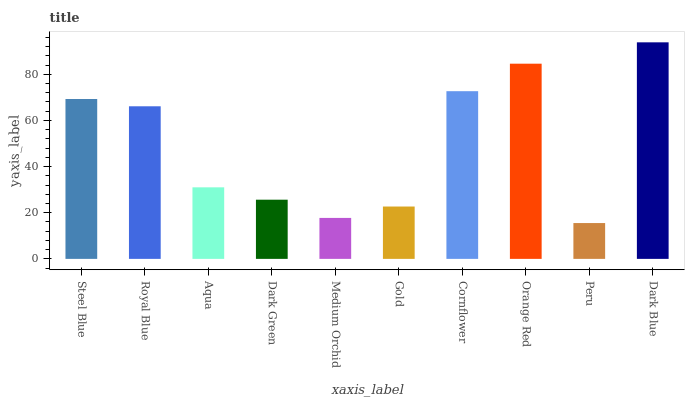Is Peru the minimum?
Answer yes or no. Yes. Is Dark Blue the maximum?
Answer yes or no. Yes. Is Royal Blue the minimum?
Answer yes or no. No. Is Royal Blue the maximum?
Answer yes or no. No. Is Steel Blue greater than Royal Blue?
Answer yes or no. Yes. Is Royal Blue less than Steel Blue?
Answer yes or no. Yes. Is Royal Blue greater than Steel Blue?
Answer yes or no. No. Is Steel Blue less than Royal Blue?
Answer yes or no. No. Is Royal Blue the high median?
Answer yes or no. Yes. Is Aqua the low median?
Answer yes or no. Yes. Is Dark Blue the high median?
Answer yes or no. No. Is Dark Green the low median?
Answer yes or no. No. 